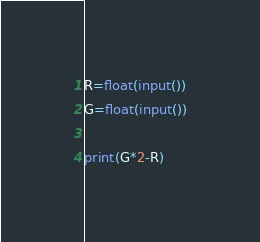Convert code to text. <code><loc_0><loc_0><loc_500><loc_500><_Python_>R=float(input())
G=float(input())

print(G*2-R)
</code> 